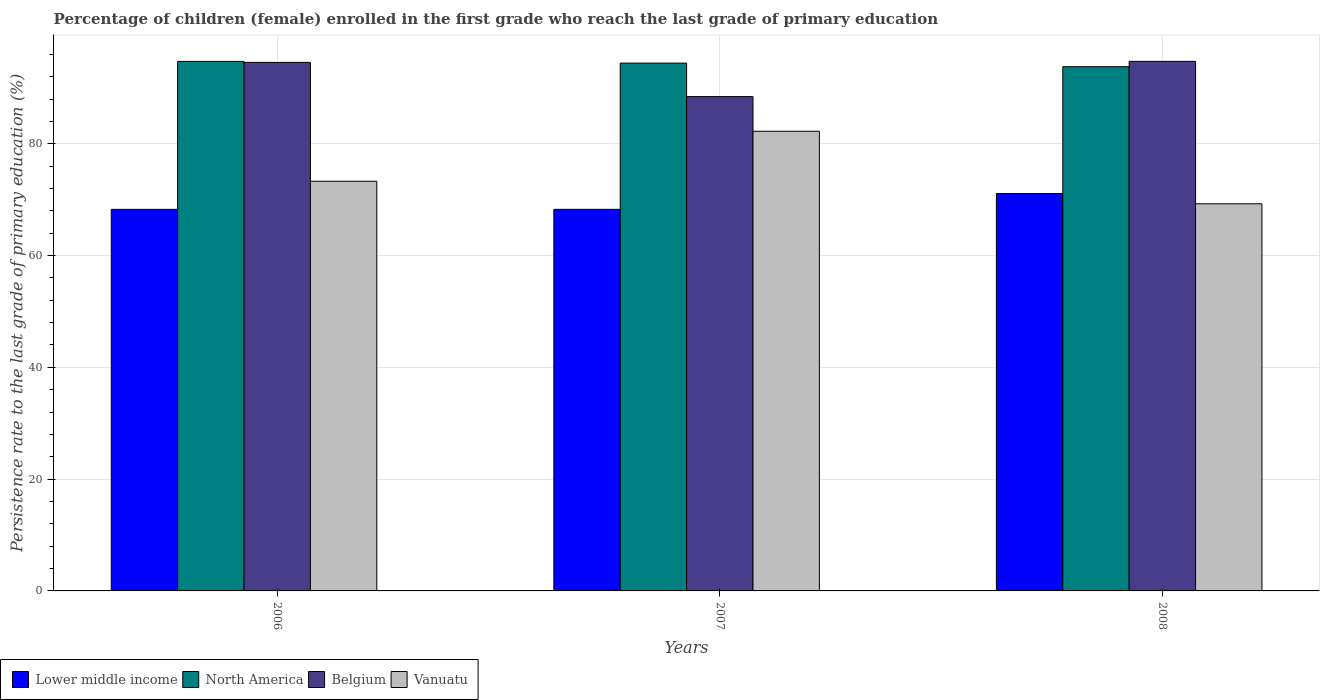How many different coloured bars are there?
Keep it short and to the point. 4. What is the label of the 3rd group of bars from the left?
Give a very brief answer. 2008. What is the persistence rate of children in Lower middle income in 2007?
Offer a terse response. 68.27. Across all years, what is the maximum persistence rate of children in Belgium?
Provide a succinct answer. 94.75. Across all years, what is the minimum persistence rate of children in Vanuatu?
Provide a short and direct response. 69.26. In which year was the persistence rate of children in Vanuatu maximum?
Ensure brevity in your answer.  2007. What is the total persistence rate of children in North America in the graph?
Make the answer very short. 282.96. What is the difference between the persistence rate of children in Belgium in 2007 and that in 2008?
Offer a very short reply. -6.31. What is the difference between the persistence rate of children in Vanuatu in 2007 and the persistence rate of children in Belgium in 2006?
Offer a terse response. -12.32. What is the average persistence rate of children in Belgium per year?
Offer a very short reply. 92.58. In the year 2006, what is the difference between the persistence rate of children in Belgium and persistence rate of children in North America?
Make the answer very short. -0.17. What is the ratio of the persistence rate of children in Vanuatu in 2006 to that in 2008?
Give a very brief answer. 1.06. Is the difference between the persistence rate of children in Belgium in 2006 and 2008 greater than the difference between the persistence rate of children in North America in 2006 and 2008?
Your response must be concise. No. What is the difference between the highest and the second highest persistence rate of children in North America?
Provide a succinct answer. 0.31. What is the difference between the highest and the lowest persistence rate of children in Lower middle income?
Keep it short and to the point. 2.83. In how many years, is the persistence rate of children in Belgium greater than the average persistence rate of children in Belgium taken over all years?
Keep it short and to the point. 2. Is the sum of the persistence rate of children in Belgium in 2007 and 2008 greater than the maximum persistence rate of children in Lower middle income across all years?
Provide a succinct answer. Yes. What does the 4th bar from the left in 2006 represents?
Your answer should be very brief. Vanuatu. What does the 4th bar from the right in 2007 represents?
Offer a very short reply. Lower middle income. Is it the case that in every year, the sum of the persistence rate of children in Lower middle income and persistence rate of children in North America is greater than the persistence rate of children in Vanuatu?
Offer a terse response. Yes. Are all the bars in the graph horizontal?
Your answer should be very brief. No. What is the difference between two consecutive major ticks on the Y-axis?
Your answer should be very brief. 20. Does the graph contain grids?
Your answer should be very brief. Yes. Where does the legend appear in the graph?
Give a very brief answer. Bottom left. How are the legend labels stacked?
Make the answer very short. Horizontal. What is the title of the graph?
Your answer should be very brief. Percentage of children (female) enrolled in the first grade who reach the last grade of primary education. Does "St. Vincent and the Grenadines" appear as one of the legend labels in the graph?
Provide a short and direct response. No. What is the label or title of the Y-axis?
Provide a short and direct response. Persistence rate to the last grade of primary education (%). What is the Persistence rate to the last grade of primary education (%) of Lower middle income in 2006?
Give a very brief answer. 68.27. What is the Persistence rate to the last grade of primary education (%) in North America in 2006?
Your answer should be compact. 94.74. What is the Persistence rate to the last grade of primary education (%) of Belgium in 2006?
Provide a succinct answer. 94.56. What is the Persistence rate to the last grade of primary education (%) of Vanuatu in 2006?
Offer a very short reply. 73.29. What is the Persistence rate to the last grade of primary education (%) in Lower middle income in 2007?
Your response must be concise. 68.27. What is the Persistence rate to the last grade of primary education (%) in North America in 2007?
Offer a very short reply. 94.43. What is the Persistence rate to the last grade of primary education (%) in Belgium in 2007?
Your response must be concise. 88.44. What is the Persistence rate to the last grade of primary education (%) of Vanuatu in 2007?
Your answer should be very brief. 82.24. What is the Persistence rate to the last grade of primary education (%) in Lower middle income in 2008?
Give a very brief answer. 71.09. What is the Persistence rate to the last grade of primary education (%) in North America in 2008?
Keep it short and to the point. 93.79. What is the Persistence rate to the last grade of primary education (%) in Belgium in 2008?
Offer a terse response. 94.75. What is the Persistence rate to the last grade of primary education (%) of Vanuatu in 2008?
Provide a short and direct response. 69.26. Across all years, what is the maximum Persistence rate to the last grade of primary education (%) in Lower middle income?
Give a very brief answer. 71.09. Across all years, what is the maximum Persistence rate to the last grade of primary education (%) of North America?
Make the answer very short. 94.74. Across all years, what is the maximum Persistence rate to the last grade of primary education (%) in Belgium?
Ensure brevity in your answer.  94.75. Across all years, what is the maximum Persistence rate to the last grade of primary education (%) in Vanuatu?
Provide a succinct answer. 82.24. Across all years, what is the minimum Persistence rate to the last grade of primary education (%) in Lower middle income?
Your answer should be compact. 68.27. Across all years, what is the minimum Persistence rate to the last grade of primary education (%) in North America?
Keep it short and to the point. 93.79. Across all years, what is the minimum Persistence rate to the last grade of primary education (%) of Belgium?
Your answer should be very brief. 88.44. Across all years, what is the minimum Persistence rate to the last grade of primary education (%) of Vanuatu?
Keep it short and to the point. 69.26. What is the total Persistence rate to the last grade of primary education (%) of Lower middle income in the graph?
Your answer should be very brief. 207.63. What is the total Persistence rate to the last grade of primary education (%) of North America in the graph?
Your response must be concise. 282.96. What is the total Persistence rate to the last grade of primary education (%) in Belgium in the graph?
Your response must be concise. 277.74. What is the total Persistence rate to the last grade of primary education (%) of Vanuatu in the graph?
Offer a terse response. 224.79. What is the difference between the Persistence rate to the last grade of primary education (%) of Lower middle income in 2006 and that in 2007?
Provide a short and direct response. -0. What is the difference between the Persistence rate to the last grade of primary education (%) of North America in 2006 and that in 2007?
Make the answer very short. 0.31. What is the difference between the Persistence rate to the last grade of primary education (%) in Belgium in 2006 and that in 2007?
Ensure brevity in your answer.  6.12. What is the difference between the Persistence rate to the last grade of primary education (%) of Vanuatu in 2006 and that in 2007?
Give a very brief answer. -8.94. What is the difference between the Persistence rate to the last grade of primary education (%) in Lower middle income in 2006 and that in 2008?
Provide a succinct answer. -2.83. What is the difference between the Persistence rate to the last grade of primary education (%) of North America in 2006 and that in 2008?
Provide a succinct answer. 0.95. What is the difference between the Persistence rate to the last grade of primary education (%) in Belgium in 2006 and that in 2008?
Keep it short and to the point. -0.18. What is the difference between the Persistence rate to the last grade of primary education (%) of Vanuatu in 2006 and that in 2008?
Your response must be concise. 4.03. What is the difference between the Persistence rate to the last grade of primary education (%) of Lower middle income in 2007 and that in 2008?
Ensure brevity in your answer.  -2.82. What is the difference between the Persistence rate to the last grade of primary education (%) in North America in 2007 and that in 2008?
Provide a short and direct response. 0.64. What is the difference between the Persistence rate to the last grade of primary education (%) of Belgium in 2007 and that in 2008?
Keep it short and to the point. -6.31. What is the difference between the Persistence rate to the last grade of primary education (%) of Vanuatu in 2007 and that in 2008?
Offer a terse response. 12.98. What is the difference between the Persistence rate to the last grade of primary education (%) of Lower middle income in 2006 and the Persistence rate to the last grade of primary education (%) of North America in 2007?
Your answer should be compact. -26.16. What is the difference between the Persistence rate to the last grade of primary education (%) in Lower middle income in 2006 and the Persistence rate to the last grade of primary education (%) in Belgium in 2007?
Provide a succinct answer. -20.17. What is the difference between the Persistence rate to the last grade of primary education (%) of Lower middle income in 2006 and the Persistence rate to the last grade of primary education (%) of Vanuatu in 2007?
Keep it short and to the point. -13.97. What is the difference between the Persistence rate to the last grade of primary education (%) of North America in 2006 and the Persistence rate to the last grade of primary education (%) of Belgium in 2007?
Keep it short and to the point. 6.3. What is the difference between the Persistence rate to the last grade of primary education (%) in North America in 2006 and the Persistence rate to the last grade of primary education (%) in Vanuatu in 2007?
Your response must be concise. 12.5. What is the difference between the Persistence rate to the last grade of primary education (%) of Belgium in 2006 and the Persistence rate to the last grade of primary education (%) of Vanuatu in 2007?
Provide a short and direct response. 12.32. What is the difference between the Persistence rate to the last grade of primary education (%) of Lower middle income in 2006 and the Persistence rate to the last grade of primary education (%) of North America in 2008?
Your answer should be very brief. -25.52. What is the difference between the Persistence rate to the last grade of primary education (%) of Lower middle income in 2006 and the Persistence rate to the last grade of primary education (%) of Belgium in 2008?
Your response must be concise. -26.48. What is the difference between the Persistence rate to the last grade of primary education (%) in Lower middle income in 2006 and the Persistence rate to the last grade of primary education (%) in Vanuatu in 2008?
Your response must be concise. -1. What is the difference between the Persistence rate to the last grade of primary education (%) in North America in 2006 and the Persistence rate to the last grade of primary education (%) in Belgium in 2008?
Provide a short and direct response. -0.01. What is the difference between the Persistence rate to the last grade of primary education (%) in North America in 2006 and the Persistence rate to the last grade of primary education (%) in Vanuatu in 2008?
Offer a terse response. 25.47. What is the difference between the Persistence rate to the last grade of primary education (%) of Belgium in 2006 and the Persistence rate to the last grade of primary education (%) of Vanuatu in 2008?
Offer a terse response. 25.3. What is the difference between the Persistence rate to the last grade of primary education (%) of Lower middle income in 2007 and the Persistence rate to the last grade of primary education (%) of North America in 2008?
Your answer should be compact. -25.52. What is the difference between the Persistence rate to the last grade of primary education (%) in Lower middle income in 2007 and the Persistence rate to the last grade of primary education (%) in Belgium in 2008?
Ensure brevity in your answer.  -26.48. What is the difference between the Persistence rate to the last grade of primary education (%) in Lower middle income in 2007 and the Persistence rate to the last grade of primary education (%) in Vanuatu in 2008?
Ensure brevity in your answer.  -0.99. What is the difference between the Persistence rate to the last grade of primary education (%) in North America in 2007 and the Persistence rate to the last grade of primary education (%) in Belgium in 2008?
Ensure brevity in your answer.  -0.32. What is the difference between the Persistence rate to the last grade of primary education (%) in North America in 2007 and the Persistence rate to the last grade of primary education (%) in Vanuatu in 2008?
Your answer should be compact. 25.17. What is the difference between the Persistence rate to the last grade of primary education (%) in Belgium in 2007 and the Persistence rate to the last grade of primary education (%) in Vanuatu in 2008?
Offer a very short reply. 19.18. What is the average Persistence rate to the last grade of primary education (%) in Lower middle income per year?
Your answer should be very brief. 69.21. What is the average Persistence rate to the last grade of primary education (%) in North America per year?
Ensure brevity in your answer.  94.32. What is the average Persistence rate to the last grade of primary education (%) in Belgium per year?
Your response must be concise. 92.58. What is the average Persistence rate to the last grade of primary education (%) in Vanuatu per year?
Make the answer very short. 74.93. In the year 2006, what is the difference between the Persistence rate to the last grade of primary education (%) in Lower middle income and Persistence rate to the last grade of primary education (%) in North America?
Keep it short and to the point. -26.47. In the year 2006, what is the difference between the Persistence rate to the last grade of primary education (%) in Lower middle income and Persistence rate to the last grade of primary education (%) in Belgium?
Your response must be concise. -26.29. In the year 2006, what is the difference between the Persistence rate to the last grade of primary education (%) in Lower middle income and Persistence rate to the last grade of primary education (%) in Vanuatu?
Give a very brief answer. -5.03. In the year 2006, what is the difference between the Persistence rate to the last grade of primary education (%) in North America and Persistence rate to the last grade of primary education (%) in Belgium?
Offer a terse response. 0.17. In the year 2006, what is the difference between the Persistence rate to the last grade of primary education (%) of North America and Persistence rate to the last grade of primary education (%) of Vanuatu?
Your response must be concise. 21.44. In the year 2006, what is the difference between the Persistence rate to the last grade of primary education (%) of Belgium and Persistence rate to the last grade of primary education (%) of Vanuatu?
Your response must be concise. 21.27. In the year 2007, what is the difference between the Persistence rate to the last grade of primary education (%) of Lower middle income and Persistence rate to the last grade of primary education (%) of North America?
Provide a succinct answer. -26.16. In the year 2007, what is the difference between the Persistence rate to the last grade of primary education (%) of Lower middle income and Persistence rate to the last grade of primary education (%) of Belgium?
Offer a terse response. -20.17. In the year 2007, what is the difference between the Persistence rate to the last grade of primary education (%) in Lower middle income and Persistence rate to the last grade of primary education (%) in Vanuatu?
Offer a very short reply. -13.97. In the year 2007, what is the difference between the Persistence rate to the last grade of primary education (%) of North America and Persistence rate to the last grade of primary education (%) of Belgium?
Your response must be concise. 5.99. In the year 2007, what is the difference between the Persistence rate to the last grade of primary education (%) of North America and Persistence rate to the last grade of primary education (%) of Vanuatu?
Offer a terse response. 12.19. In the year 2007, what is the difference between the Persistence rate to the last grade of primary education (%) of Belgium and Persistence rate to the last grade of primary education (%) of Vanuatu?
Make the answer very short. 6.2. In the year 2008, what is the difference between the Persistence rate to the last grade of primary education (%) of Lower middle income and Persistence rate to the last grade of primary education (%) of North America?
Ensure brevity in your answer.  -22.7. In the year 2008, what is the difference between the Persistence rate to the last grade of primary education (%) in Lower middle income and Persistence rate to the last grade of primary education (%) in Belgium?
Offer a very short reply. -23.65. In the year 2008, what is the difference between the Persistence rate to the last grade of primary education (%) of Lower middle income and Persistence rate to the last grade of primary education (%) of Vanuatu?
Ensure brevity in your answer.  1.83. In the year 2008, what is the difference between the Persistence rate to the last grade of primary education (%) of North America and Persistence rate to the last grade of primary education (%) of Belgium?
Ensure brevity in your answer.  -0.95. In the year 2008, what is the difference between the Persistence rate to the last grade of primary education (%) of North America and Persistence rate to the last grade of primary education (%) of Vanuatu?
Offer a very short reply. 24.53. In the year 2008, what is the difference between the Persistence rate to the last grade of primary education (%) in Belgium and Persistence rate to the last grade of primary education (%) in Vanuatu?
Your answer should be compact. 25.48. What is the ratio of the Persistence rate to the last grade of primary education (%) in Lower middle income in 2006 to that in 2007?
Give a very brief answer. 1. What is the ratio of the Persistence rate to the last grade of primary education (%) in North America in 2006 to that in 2007?
Your answer should be very brief. 1. What is the ratio of the Persistence rate to the last grade of primary education (%) of Belgium in 2006 to that in 2007?
Keep it short and to the point. 1.07. What is the ratio of the Persistence rate to the last grade of primary education (%) in Vanuatu in 2006 to that in 2007?
Your response must be concise. 0.89. What is the ratio of the Persistence rate to the last grade of primary education (%) in Lower middle income in 2006 to that in 2008?
Provide a short and direct response. 0.96. What is the ratio of the Persistence rate to the last grade of primary education (%) in Vanuatu in 2006 to that in 2008?
Offer a terse response. 1.06. What is the ratio of the Persistence rate to the last grade of primary education (%) of Lower middle income in 2007 to that in 2008?
Provide a short and direct response. 0.96. What is the ratio of the Persistence rate to the last grade of primary education (%) of North America in 2007 to that in 2008?
Keep it short and to the point. 1.01. What is the ratio of the Persistence rate to the last grade of primary education (%) in Belgium in 2007 to that in 2008?
Provide a succinct answer. 0.93. What is the ratio of the Persistence rate to the last grade of primary education (%) of Vanuatu in 2007 to that in 2008?
Offer a very short reply. 1.19. What is the difference between the highest and the second highest Persistence rate to the last grade of primary education (%) in Lower middle income?
Your answer should be compact. 2.82. What is the difference between the highest and the second highest Persistence rate to the last grade of primary education (%) of North America?
Provide a short and direct response. 0.31. What is the difference between the highest and the second highest Persistence rate to the last grade of primary education (%) in Belgium?
Give a very brief answer. 0.18. What is the difference between the highest and the second highest Persistence rate to the last grade of primary education (%) of Vanuatu?
Make the answer very short. 8.94. What is the difference between the highest and the lowest Persistence rate to the last grade of primary education (%) in Lower middle income?
Ensure brevity in your answer.  2.83. What is the difference between the highest and the lowest Persistence rate to the last grade of primary education (%) in North America?
Your answer should be very brief. 0.95. What is the difference between the highest and the lowest Persistence rate to the last grade of primary education (%) in Belgium?
Keep it short and to the point. 6.31. What is the difference between the highest and the lowest Persistence rate to the last grade of primary education (%) in Vanuatu?
Give a very brief answer. 12.98. 